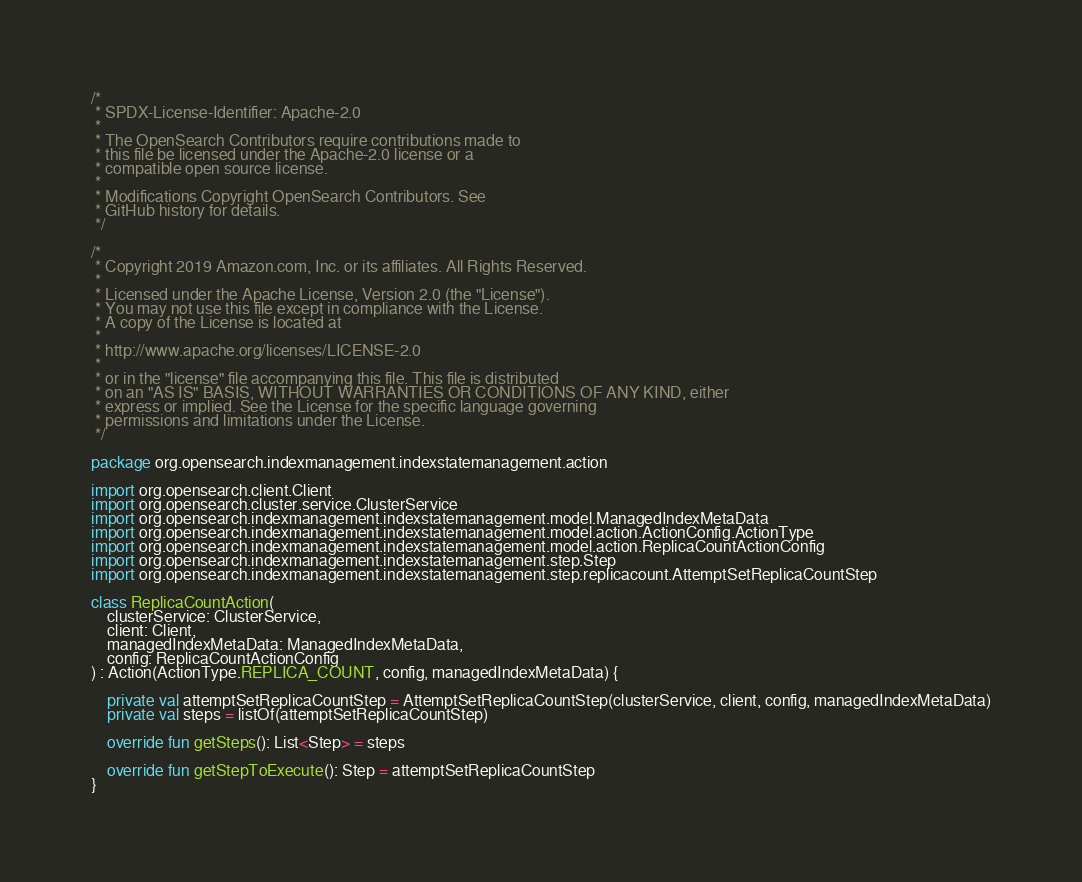Convert code to text. <code><loc_0><loc_0><loc_500><loc_500><_Kotlin_>/*
 * SPDX-License-Identifier: Apache-2.0
 *
 * The OpenSearch Contributors require contributions made to
 * this file be licensed under the Apache-2.0 license or a
 * compatible open source license.
 *
 * Modifications Copyright OpenSearch Contributors. See
 * GitHub history for details.
 */

/*
 * Copyright 2019 Amazon.com, Inc. or its affiliates. All Rights Reserved.
 *
 * Licensed under the Apache License, Version 2.0 (the "License").
 * You may not use this file except in compliance with the License.
 * A copy of the License is located at
 *
 * http://www.apache.org/licenses/LICENSE-2.0
 *
 * or in the "license" file accompanying this file. This file is distributed
 * on an "AS IS" BASIS, WITHOUT WARRANTIES OR CONDITIONS OF ANY KIND, either
 * express or implied. See the License for the specific language governing
 * permissions and limitations under the License.
 */

package org.opensearch.indexmanagement.indexstatemanagement.action

import org.opensearch.client.Client
import org.opensearch.cluster.service.ClusterService
import org.opensearch.indexmanagement.indexstatemanagement.model.ManagedIndexMetaData
import org.opensearch.indexmanagement.indexstatemanagement.model.action.ActionConfig.ActionType
import org.opensearch.indexmanagement.indexstatemanagement.model.action.ReplicaCountActionConfig
import org.opensearch.indexmanagement.indexstatemanagement.step.Step
import org.opensearch.indexmanagement.indexstatemanagement.step.replicacount.AttemptSetReplicaCountStep

class ReplicaCountAction(
    clusterService: ClusterService,
    client: Client,
    managedIndexMetaData: ManagedIndexMetaData,
    config: ReplicaCountActionConfig
) : Action(ActionType.REPLICA_COUNT, config, managedIndexMetaData) {

    private val attemptSetReplicaCountStep = AttemptSetReplicaCountStep(clusterService, client, config, managedIndexMetaData)
    private val steps = listOf(attemptSetReplicaCountStep)

    override fun getSteps(): List<Step> = steps

    override fun getStepToExecute(): Step = attemptSetReplicaCountStep
}
</code> 